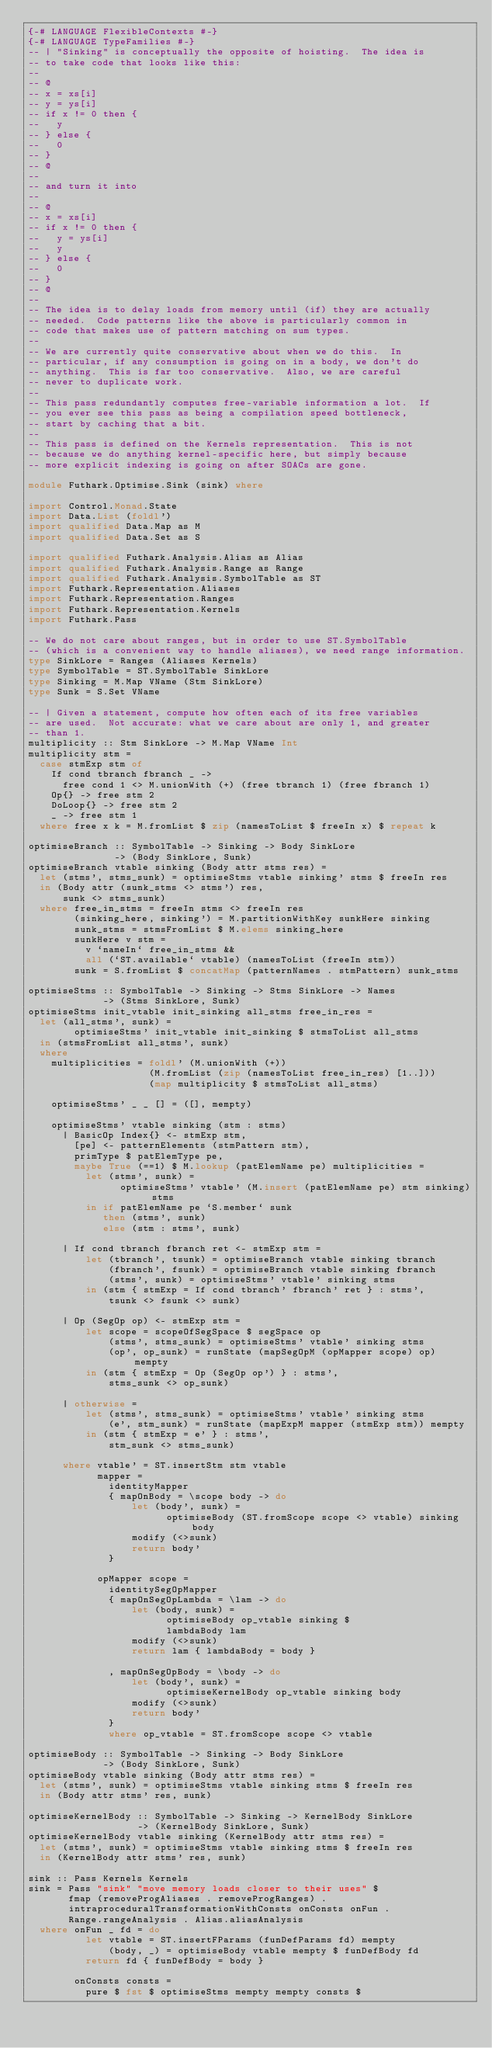Convert code to text. <code><loc_0><loc_0><loc_500><loc_500><_Haskell_>{-# LANGUAGE FlexibleContexts #-}
{-# LANGUAGE TypeFamilies #-}
-- | "Sinking" is conceptually the opposite of hoisting.  The idea is
-- to take code that looks like this:
--
-- @
-- x = xs[i]
-- y = ys[i]
-- if x != 0 then {
--   y
-- } else {
--   0
-- }
-- @
--
-- and turn it into
--
-- @
-- x = xs[i]
-- if x != 0 then {
--   y = ys[i]
--   y
-- } else {
--   0
-- }
-- @
--
-- The idea is to delay loads from memory until (if) they are actually
-- needed.  Code patterns like the above is particularly common in
-- code that makes use of pattern matching on sum types.
--
-- We are currently quite conservative about when we do this.  In
-- particular, if any consumption is going on in a body, we don't do
-- anything.  This is far too conservative.  Also, we are careful
-- never to duplicate work.
--
-- This pass redundantly computes free-variable information a lot.  If
-- you ever see this pass as being a compilation speed bottleneck,
-- start by caching that a bit.
--
-- This pass is defined on the Kernels representation.  This is not
-- because we do anything kernel-specific here, but simply because
-- more explicit indexing is going on after SOACs are gone.

module Futhark.Optimise.Sink (sink) where

import Control.Monad.State
import Data.List (foldl')
import qualified Data.Map as M
import qualified Data.Set as S

import qualified Futhark.Analysis.Alias as Alias
import qualified Futhark.Analysis.Range as Range
import qualified Futhark.Analysis.SymbolTable as ST
import Futhark.Representation.Aliases
import Futhark.Representation.Ranges
import Futhark.Representation.Kernels
import Futhark.Pass

-- We do not care about ranges, but in order to use ST.SymbolTable
-- (which is a convenient way to handle aliases), we need range information.
type SinkLore = Ranges (Aliases Kernels)
type SymbolTable = ST.SymbolTable SinkLore
type Sinking = M.Map VName (Stm SinkLore)
type Sunk = S.Set VName

-- | Given a statement, compute how often each of its free variables
-- are used.  Not accurate: what we care about are only 1, and greater
-- than 1.
multiplicity :: Stm SinkLore -> M.Map VName Int
multiplicity stm =
  case stmExp stm of
    If cond tbranch fbranch _ ->
      free cond 1 <> M.unionWith (+) (free tbranch 1) (free fbranch 1)
    Op{} -> free stm 2
    DoLoop{} -> free stm 2
    _ -> free stm 1
  where free x k = M.fromList $ zip (namesToList $ freeIn x) $ repeat k

optimiseBranch :: SymbolTable -> Sinking -> Body SinkLore
               -> (Body SinkLore, Sunk)
optimiseBranch vtable sinking (Body attr stms res) =
  let (stms', stms_sunk) = optimiseStms vtable sinking' stms $ freeIn res
  in (Body attr (sunk_stms <> stms') res,
      sunk <> stms_sunk)
  where free_in_stms = freeIn stms <> freeIn res
        (sinking_here, sinking') = M.partitionWithKey sunkHere sinking
        sunk_stms = stmsFromList $ M.elems sinking_here
        sunkHere v stm =
          v `nameIn` free_in_stms &&
          all (`ST.available` vtable) (namesToList (freeIn stm))
        sunk = S.fromList $ concatMap (patternNames . stmPattern) sunk_stms

optimiseStms :: SymbolTable -> Sinking -> Stms SinkLore -> Names
             -> (Stms SinkLore, Sunk)
optimiseStms init_vtable init_sinking all_stms free_in_res =
  let (all_stms', sunk) =
        optimiseStms' init_vtable init_sinking $ stmsToList all_stms
  in (stmsFromList all_stms', sunk)
  where
    multiplicities = foldl' (M.unionWith (+))
                     (M.fromList (zip (namesToList free_in_res) [1..]))
                     (map multiplicity $ stmsToList all_stms)

    optimiseStms' _ _ [] = ([], mempty)

    optimiseStms' vtable sinking (stm : stms)
      | BasicOp Index{} <- stmExp stm,
        [pe] <- patternElements (stmPattern stm),
        primType $ patElemType pe,
        maybe True (==1) $ M.lookup (patElemName pe) multiplicities =
          let (stms', sunk) =
                optimiseStms' vtable' (M.insert (patElemName pe) stm sinking) stms
          in if patElemName pe `S.member` sunk
             then (stms', sunk)
             else (stm : stms', sunk)

      | If cond tbranch fbranch ret <- stmExp stm =
          let (tbranch', tsunk) = optimiseBranch vtable sinking tbranch
              (fbranch', fsunk) = optimiseBranch vtable sinking fbranch
              (stms', sunk) = optimiseStms' vtable' sinking stms
          in (stm { stmExp = If cond tbranch' fbranch' ret } : stms',
              tsunk <> fsunk <> sunk)

      | Op (SegOp op) <- stmExp stm =
          let scope = scopeOfSegSpace $ segSpace op
              (stms', stms_sunk) = optimiseStms' vtable' sinking stms
              (op', op_sunk) = runState (mapSegOpM (opMapper scope) op) mempty
          in (stm { stmExp = Op (SegOp op') } : stms',
              stms_sunk <> op_sunk)

      | otherwise =
          let (stms', stms_sunk) = optimiseStms' vtable' sinking stms
              (e', stm_sunk) = runState (mapExpM mapper (stmExp stm)) mempty
          in (stm { stmExp = e' } : stms',
              stm_sunk <> stms_sunk)

      where vtable' = ST.insertStm stm vtable
            mapper =
              identityMapper
              { mapOnBody = \scope body -> do
                  let (body', sunk) =
                        optimiseBody (ST.fromScope scope <> vtable) sinking body
                  modify (<>sunk)
                  return body'
              }

            opMapper scope =
              identitySegOpMapper
              { mapOnSegOpLambda = \lam -> do
                  let (body, sunk) =
                        optimiseBody op_vtable sinking $
                        lambdaBody lam
                  modify (<>sunk)
                  return lam { lambdaBody = body }

              , mapOnSegOpBody = \body -> do
                  let (body', sunk) =
                        optimiseKernelBody op_vtable sinking body
                  modify (<>sunk)
                  return body'
              }
              where op_vtable = ST.fromScope scope <> vtable

optimiseBody :: SymbolTable -> Sinking -> Body SinkLore
             -> (Body SinkLore, Sunk)
optimiseBody vtable sinking (Body attr stms res) =
  let (stms', sunk) = optimiseStms vtable sinking stms $ freeIn res
  in (Body attr stms' res, sunk)

optimiseKernelBody :: SymbolTable -> Sinking -> KernelBody SinkLore
                   -> (KernelBody SinkLore, Sunk)
optimiseKernelBody vtable sinking (KernelBody attr stms res) =
  let (stms', sunk) = optimiseStms vtable sinking stms $ freeIn res
  in (KernelBody attr stms' res, sunk)

sink :: Pass Kernels Kernels
sink = Pass "sink" "move memory loads closer to their uses" $
       fmap (removeProgAliases . removeProgRanges) .
       intraproceduralTransformationWithConsts onConsts onFun .
       Range.rangeAnalysis . Alias.aliasAnalysis
  where onFun _ fd = do
          let vtable = ST.insertFParams (funDefParams fd) mempty
              (body, _) = optimiseBody vtable mempty $ funDefBody fd
          return fd { funDefBody = body }

        onConsts consts =
          pure $ fst $ optimiseStms mempty mempty consts $</code> 